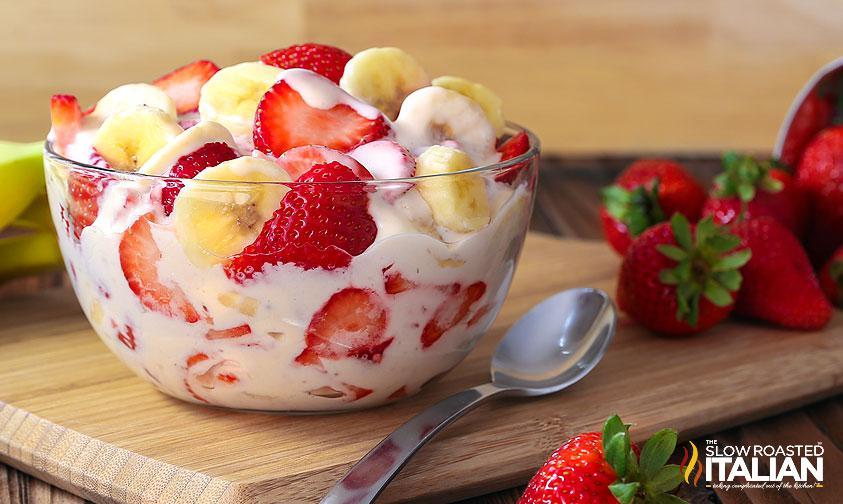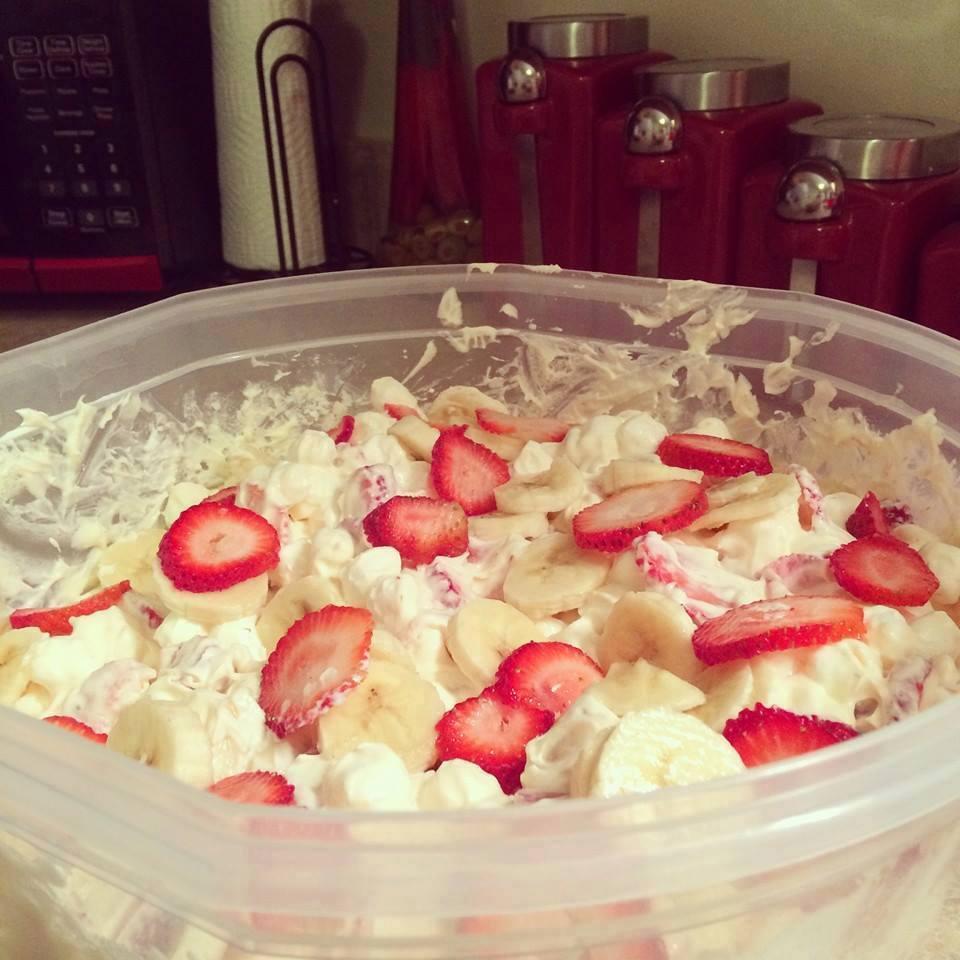The first image is the image on the left, the second image is the image on the right. Assess this claim about the two images: "There is cutlery outside of the bowl.". Correct or not? Answer yes or no. Yes. The first image is the image on the left, the second image is the image on the right. Assess this claim about the two images: "An image shows a round bowl of fruit dessert sitting on a wood-grain board, with a piece of silverware laying flat on the right side of the bowl.". Correct or not? Answer yes or no. Yes. 